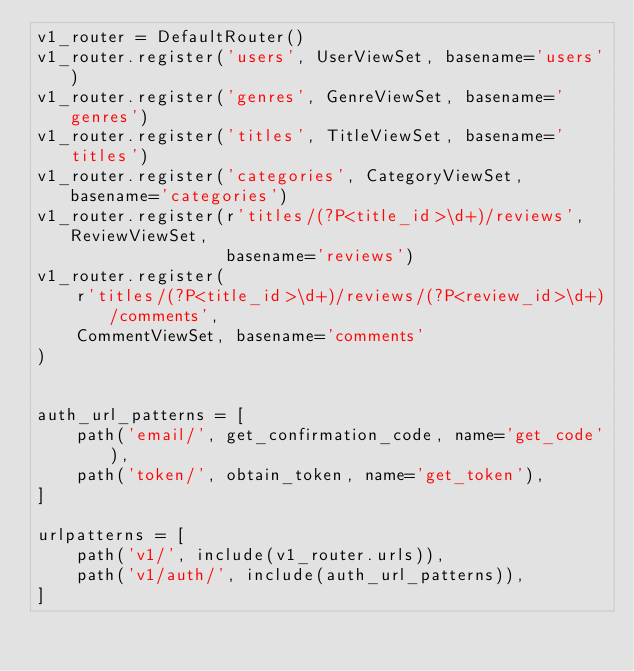Convert code to text. <code><loc_0><loc_0><loc_500><loc_500><_Python_>v1_router = DefaultRouter()
v1_router.register('users', UserViewSet, basename='users')
v1_router.register('genres', GenreViewSet, basename='genres')
v1_router.register('titles', TitleViewSet, basename='titles')
v1_router.register('categories', CategoryViewSet, basename='categories')
v1_router.register(r'titles/(?P<title_id>\d+)/reviews', ReviewViewSet,
                   basename='reviews')
v1_router.register(
    r'titles/(?P<title_id>\d+)/reviews/(?P<review_id>\d+)/comments',
    CommentViewSet, basename='comments'
)


auth_url_patterns = [
    path('email/', get_confirmation_code, name='get_code'),
    path('token/', obtain_token, name='get_token'),
]

urlpatterns = [
    path('v1/', include(v1_router.urls)),
    path('v1/auth/', include(auth_url_patterns)),
]
</code> 